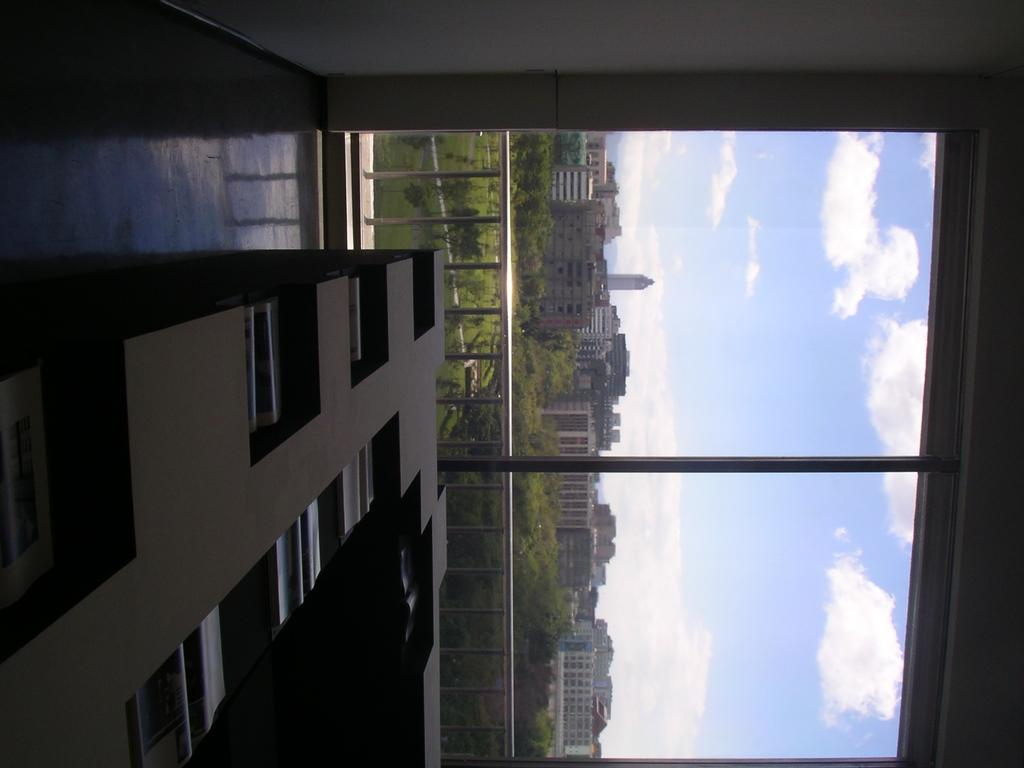What type of structures can be seen in the image? There are buildings in the image. What natural elements are present in the image? There are trees in the image. What is the pole used for in the image? The pole's purpose is not specified, but it is visible in the image. What type of material is used for the rods in the image? The rods in the image are made of metal. What can be seen in the background of the image? There are clouds visible in the background of the image. Can you identify the face of the spy in the image? There is no spy or face present in the image; it features buildings, trees, a pole, metal rods, and clouds. 